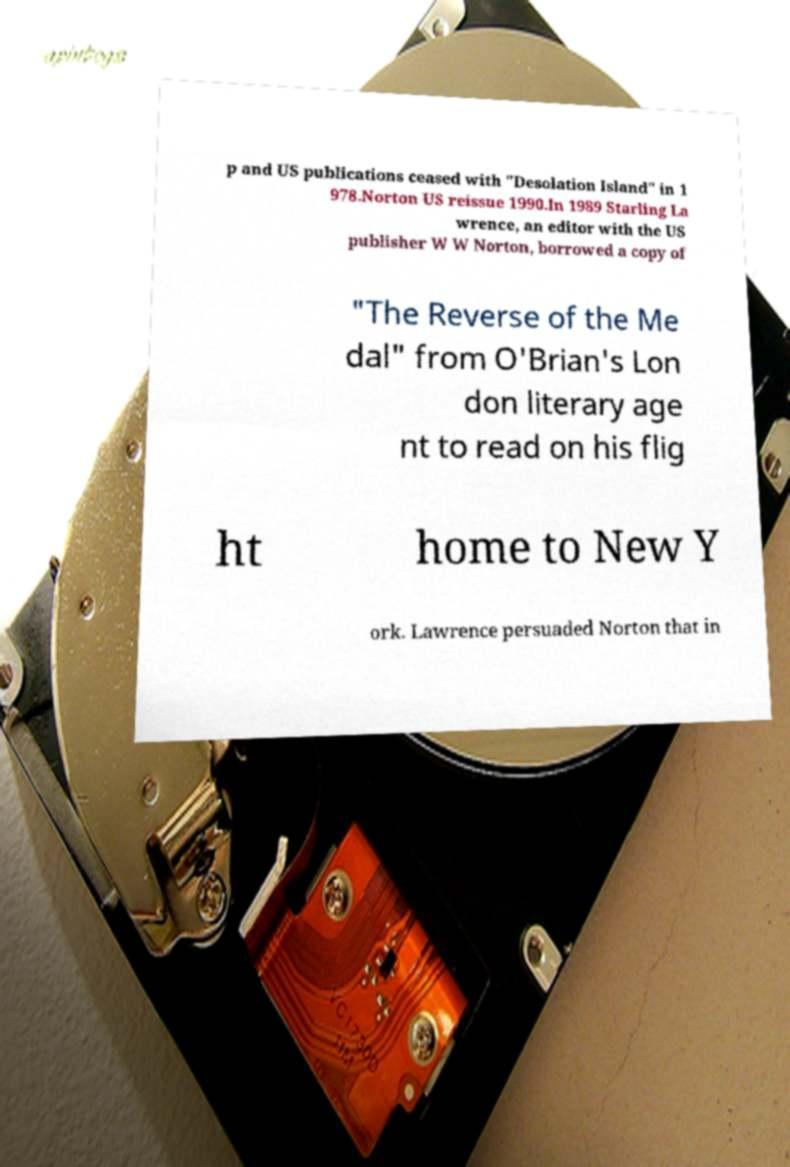For documentation purposes, I need the text within this image transcribed. Could you provide that? p and US publications ceased with "Desolation Island" in 1 978.Norton US reissue 1990.In 1989 Starling La wrence, an editor with the US publisher W W Norton, borrowed a copy of "The Reverse of the Me dal" from O'Brian's Lon don literary age nt to read on his flig ht home to New Y ork. Lawrence persuaded Norton that in 